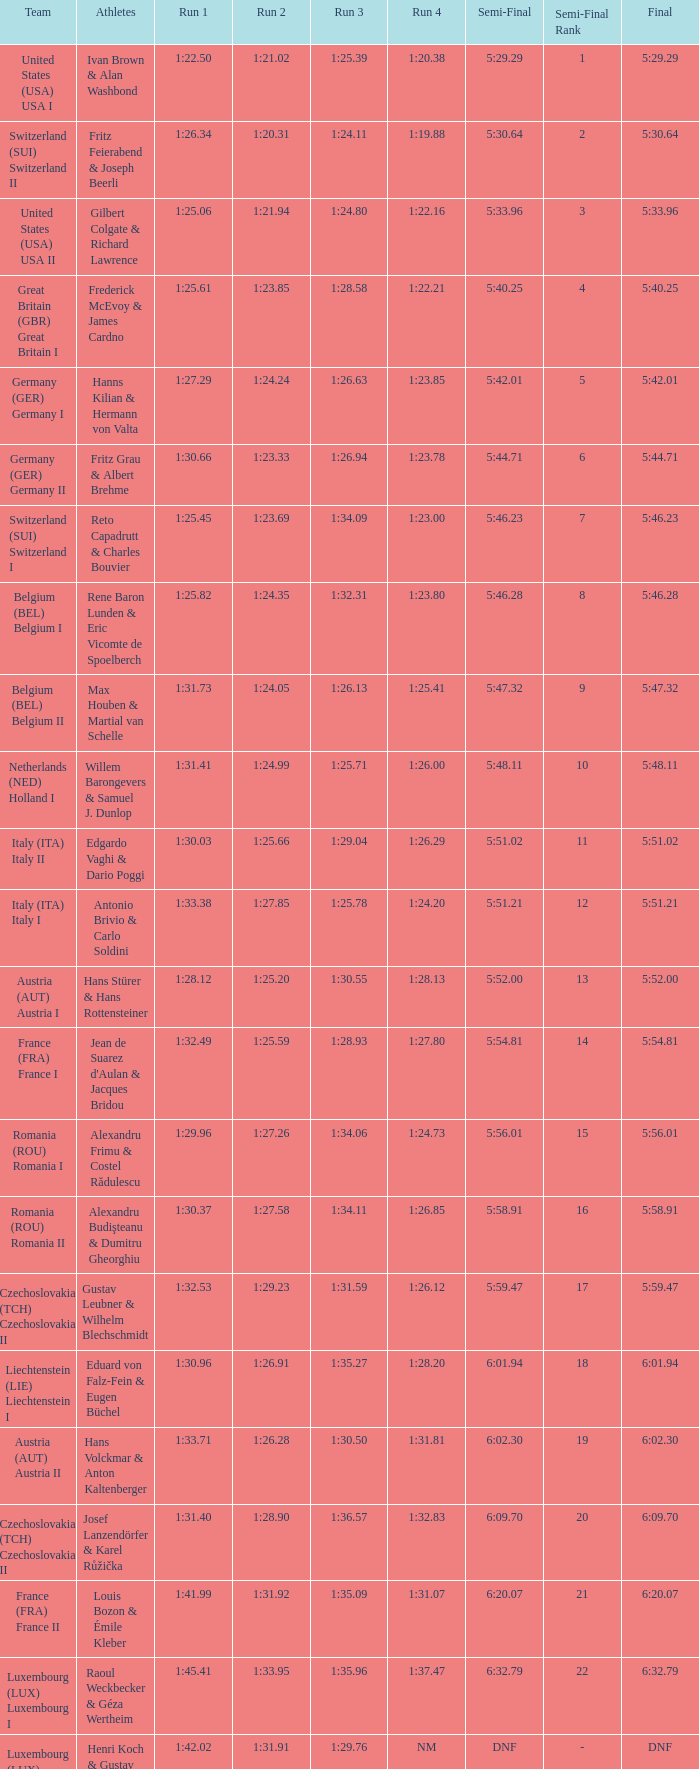Which Run 4 has a Run 1 of 1:25.82? 1:23.80. Could you parse the entire table as a dict? {'header': ['Team', 'Athletes', 'Run 1', 'Run 2', 'Run 3', 'Run 4', 'Semi-Final', 'Semi-Final Rank', 'Final'], 'rows': [['United States (USA) USA I', 'Ivan Brown & Alan Washbond', '1:22.50', '1:21.02', '1:25.39', '1:20.38', '5:29.29', '1', '5:29.29'], ['Switzerland (SUI) Switzerland II', 'Fritz Feierabend & Joseph Beerli', '1:26.34', '1:20.31', '1:24.11', '1:19.88', '5:30.64', '2', '5:30.64'], ['United States (USA) USA II', 'Gilbert Colgate & Richard Lawrence', '1:25.06', '1:21.94', '1:24.80', '1:22.16', '5:33.96', '3', '5:33.96'], ['Great Britain (GBR) Great Britain I', 'Frederick McEvoy & James Cardno', '1:25.61', '1:23.85', '1:28.58', '1:22.21', '5:40.25', '4', '5:40.25'], ['Germany (GER) Germany I', 'Hanns Kilian & Hermann von Valta', '1:27.29', '1:24.24', '1:26.63', '1:23.85', '5:42.01', '5', '5:42.01'], ['Germany (GER) Germany II', 'Fritz Grau & Albert Brehme', '1:30.66', '1:23.33', '1:26.94', '1:23.78', '5:44.71', '6', '5:44.71'], ['Switzerland (SUI) Switzerland I', 'Reto Capadrutt & Charles Bouvier', '1:25.45', '1:23.69', '1:34.09', '1:23.00', '5:46.23', '7', '5:46.23'], ['Belgium (BEL) Belgium I', 'Rene Baron Lunden & Eric Vicomte de Spoelberch', '1:25.82', '1:24.35', '1:32.31', '1:23.80', '5:46.28', '8', '5:46.28'], ['Belgium (BEL) Belgium II', 'Max Houben & Martial van Schelle', '1:31.73', '1:24.05', '1:26.13', '1:25.41', '5:47.32', '9', '5:47.32'], ['Netherlands (NED) Holland I', 'Willem Barongevers & Samuel J. Dunlop', '1:31.41', '1:24.99', '1:25.71', '1:26.00', '5:48.11', '10', '5:48.11'], ['Italy (ITA) Italy II', 'Edgardo Vaghi & Dario Poggi', '1:30.03', '1:25.66', '1:29.04', '1:26.29', '5:51.02', '11', '5:51.02'], ['Italy (ITA) Italy I', 'Antonio Brivio & Carlo Soldini', '1:33.38', '1:27.85', '1:25.78', '1:24.20', '5:51.21', '12', '5:51.21'], ['Austria (AUT) Austria I', 'Hans Stürer & Hans Rottensteiner', '1:28.12', '1:25.20', '1:30.55', '1:28.13', '5:52.00', '13', '5:52.00'], ['France (FRA) France I', "Jean de Suarez d'Aulan & Jacques Bridou", '1:32.49', '1:25.59', '1:28.93', '1:27.80', '5:54.81', '14', '5:54.81'], ['Romania (ROU) Romania I', 'Alexandru Frimu & Costel Rădulescu', '1:29.96', '1:27.26', '1:34.06', '1:24.73', '5:56.01', '15', '5:56.01'], ['Romania (ROU) Romania II', 'Alexandru Budişteanu & Dumitru Gheorghiu', '1:30.37', '1:27.58', '1:34.11', '1:26.85', '5:58.91', '16', '5:58.91'], ['Czechoslovakia (TCH) Czechoslovakia II', 'Gustav Leubner & Wilhelm Blechschmidt', '1:32.53', '1:29.23', '1:31.59', '1:26.12', '5:59.47', '17', '5:59.47'], ['Liechtenstein (LIE) Liechtenstein I', 'Eduard von Falz-Fein & Eugen Büchel', '1:30.96', '1:26.91', '1:35.27', '1:28.20', '6:01.94', '18', '6:01.94'], ['Austria (AUT) Austria II', 'Hans Volckmar & Anton Kaltenberger', '1:33.71', '1:26.28', '1:30.50', '1:31.81', '6:02.30', '19', '6:02.30'], ['Czechoslovakia (TCH) Czechoslovakia II', 'Josef Lanzendörfer & Karel Růžička', '1:31.40', '1:28.90', '1:36.57', '1:32.83', '6:09.70', '20', '6:09.70'], ['France (FRA) France II', 'Louis Bozon & Émile Kleber', '1:41.99', '1:31.92', '1:35.09', '1:31.07', '6:20.07', '21', '6:20.07'], ['Luxembourg (LUX) Luxembourg I', 'Raoul Weckbecker & Géza Wertheim', '1:45.41', '1:33.95', '1:35.96', '1:37.47', '6:32.79', '22', '6:32.79'], ['Luxembourg (LUX) Luxembourg II', 'Henri Koch & Gustav Wagner', '1:42.02', '1:31.91', '1:29.76', 'NM', 'DNF', '-', 'DNF']]} 